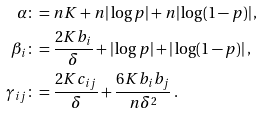<formula> <loc_0><loc_0><loc_500><loc_500>\alpha & \colon = n K + n | \log p | + n | \log ( 1 - p ) | \, , \\ \beta _ { i } & \colon = \frac { 2 K b _ { i } } { \delta } + | \log p | + | \log ( 1 - p ) | \, , \\ \gamma _ { i j } & \colon = \frac { 2 K c _ { i j } } { \delta } + \frac { 6 K b _ { i } b _ { j } } { n \delta ^ { 2 } } \, .</formula> 